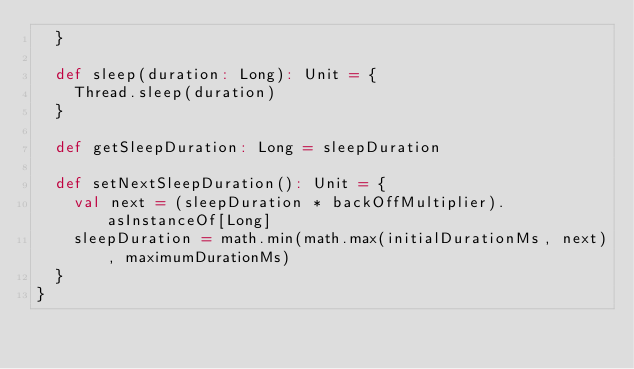<code> <loc_0><loc_0><loc_500><loc_500><_Scala_>  }

  def sleep(duration: Long): Unit = {
    Thread.sleep(duration)
  }

  def getSleepDuration: Long = sleepDuration

  def setNextSleepDuration(): Unit = {
    val next = (sleepDuration * backOffMultiplier).asInstanceOf[Long]
    sleepDuration = math.min(math.max(initialDurationMs, next), maximumDurationMs)
  }
}
</code> 